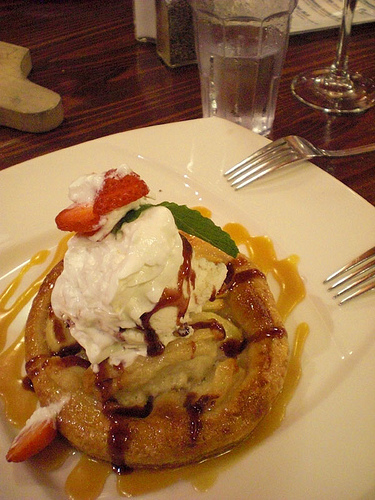<image>
Is there a fork on the strawberry? No. The fork is not positioned on the strawberry. They may be near each other, but the fork is not supported by or resting on top of the strawberry. Is there a dessert on the fork? No. The dessert is not positioned on the fork. They may be near each other, but the dessert is not supported by or resting on top of the fork. Is there a fork in the whipped cream? No. The fork is not contained within the whipped cream. These objects have a different spatial relationship. 